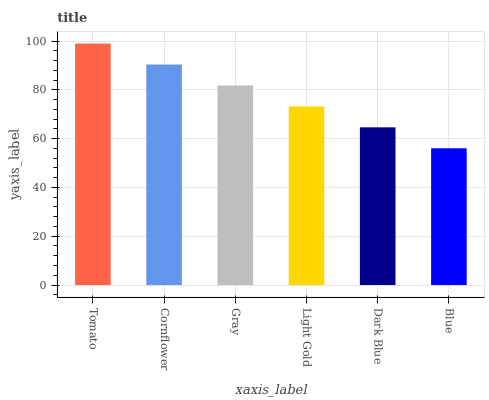Is Blue the minimum?
Answer yes or no. Yes. Is Tomato the maximum?
Answer yes or no. Yes. Is Cornflower the minimum?
Answer yes or no. No. Is Cornflower the maximum?
Answer yes or no. No. Is Tomato greater than Cornflower?
Answer yes or no. Yes. Is Cornflower less than Tomato?
Answer yes or no. Yes. Is Cornflower greater than Tomato?
Answer yes or no. No. Is Tomato less than Cornflower?
Answer yes or no. No. Is Gray the high median?
Answer yes or no. Yes. Is Light Gold the low median?
Answer yes or no. Yes. Is Light Gold the high median?
Answer yes or no. No. Is Cornflower the low median?
Answer yes or no. No. 